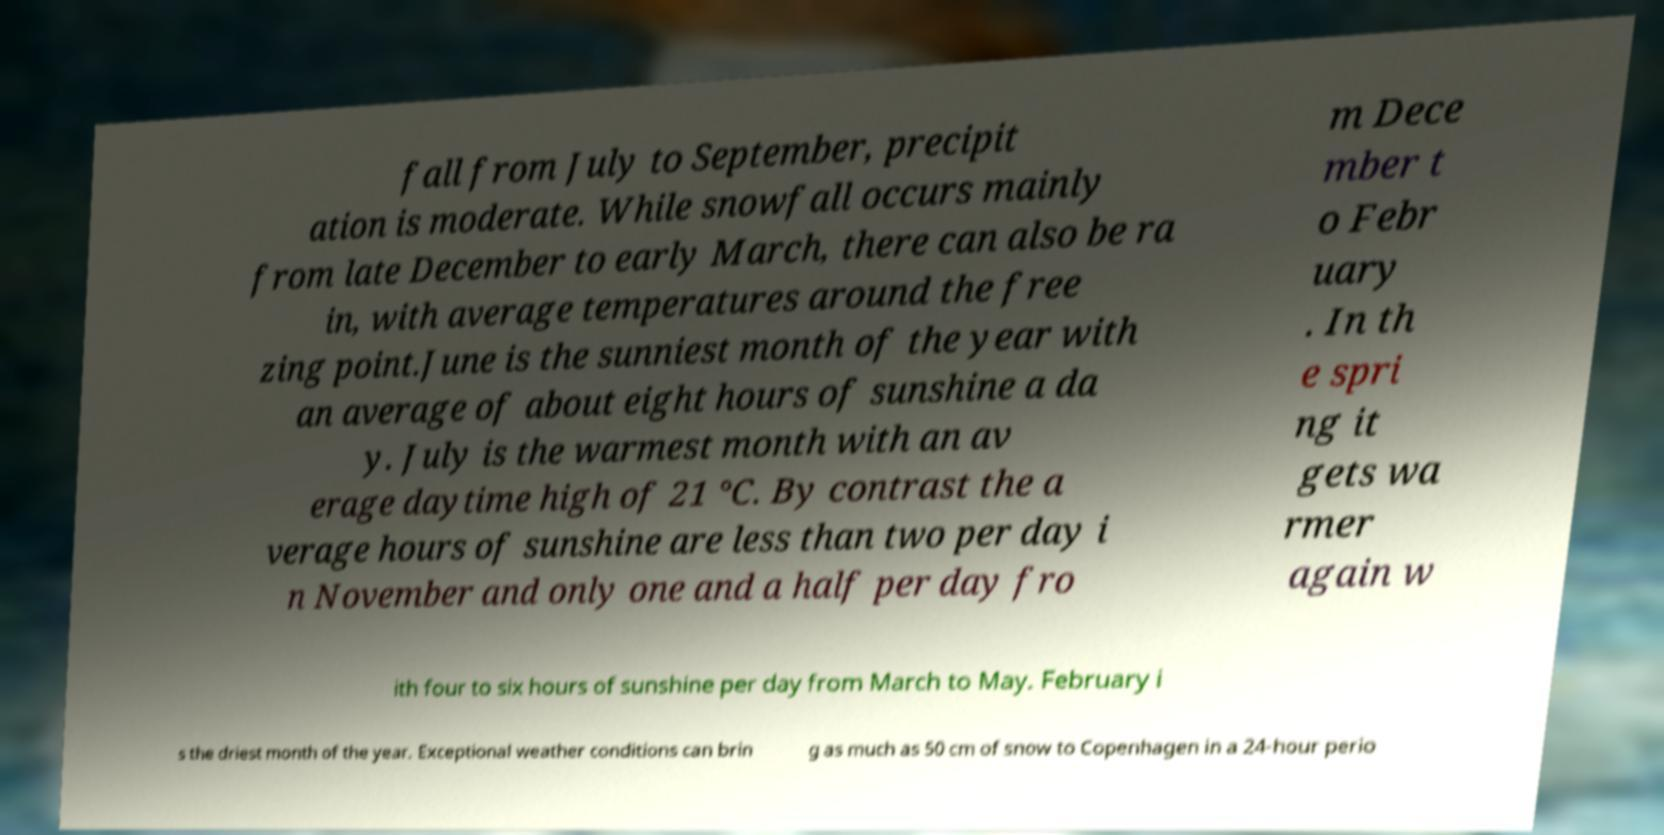Please read and relay the text visible in this image. What does it say? fall from July to September, precipit ation is moderate. While snowfall occurs mainly from late December to early March, there can also be ra in, with average temperatures around the free zing point.June is the sunniest month of the year with an average of about eight hours of sunshine a da y. July is the warmest month with an av erage daytime high of 21 °C. By contrast the a verage hours of sunshine are less than two per day i n November and only one and a half per day fro m Dece mber t o Febr uary . In th e spri ng it gets wa rmer again w ith four to six hours of sunshine per day from March to May. February i s the driest month of the year. Exceptional weather conditions can brin g as much as 50 cm of snow to Copenhagen in a 24-hour perio 